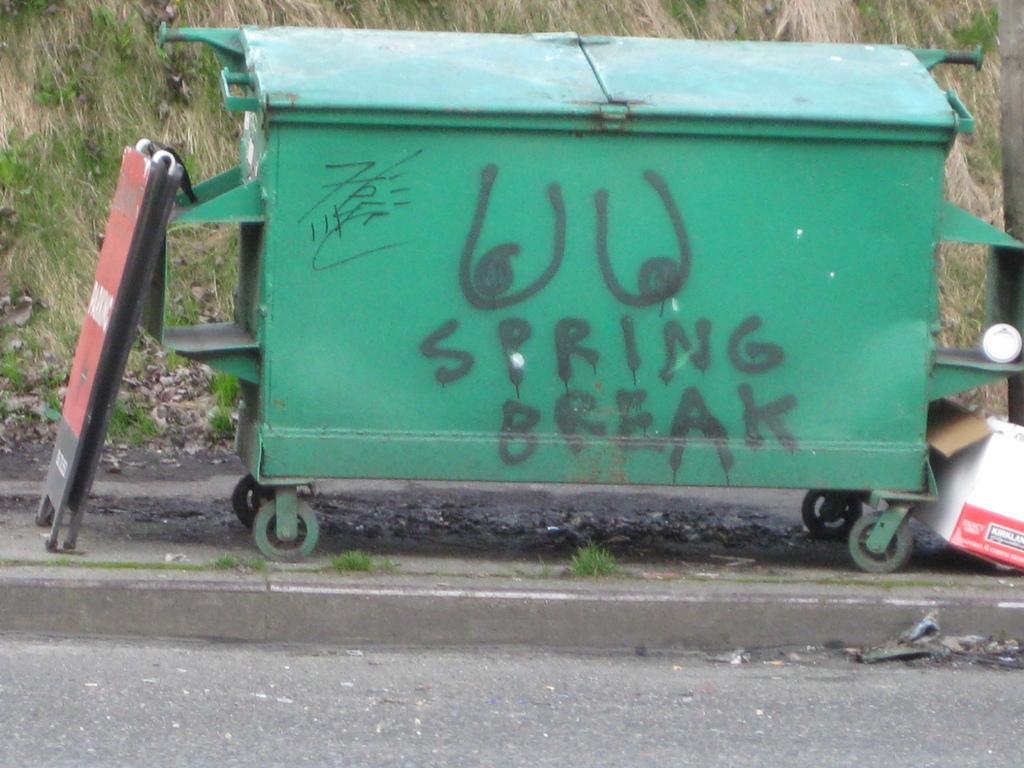What type of break is written in graffiti on the dumpster?
Give a very brief answer. Spring break. What type of body part is drawn on the dumpster?
Offer a terse response. Breasts. 